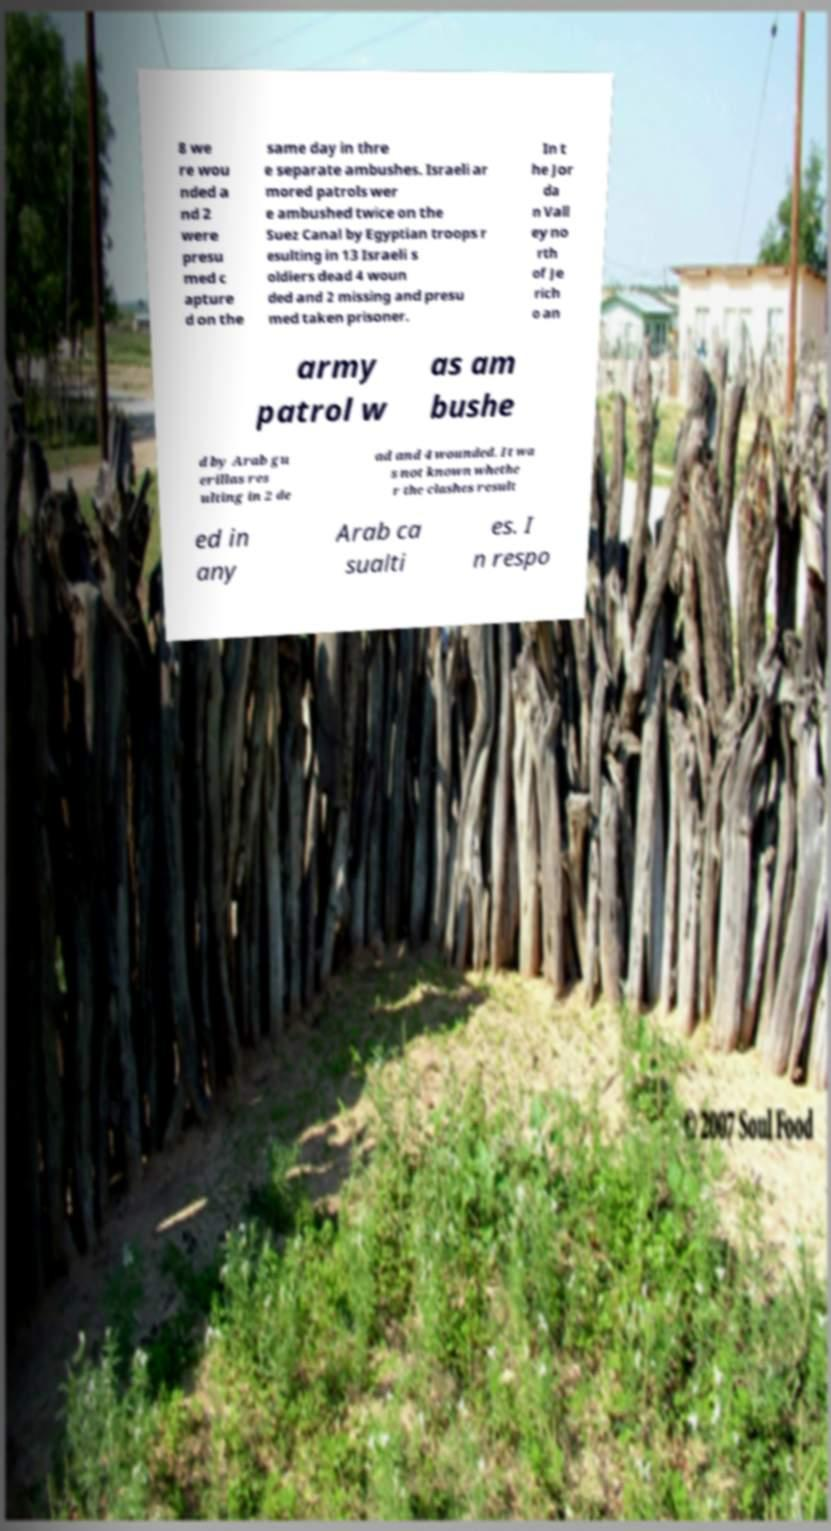I need the written content from this picture converted into text. Can you do that? 8 we re wou nded a nd 2 were presu med c apture d on the same day in thre e separate ambushes. Israeli ar mored patrols wer e ambushed twice on the Suez Canal by Egyptian troops r esulting in 13 Israeli s oldiers dead 4 woun ded and 2 missing and presu med taken prisoner. In t he Jor da n Vall ey no rth of Je rich o an army patrol w as am bushe d by Arab gu erillas res ulting in 2 de ad and 4 wounded. It wa s not known whethe r the clashes result ed in any Arab ca sualti es. I n respo 